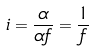<formula> <loc_0><loc_0><loc_500><loc_500>i = \frac { \alpha } { \alpha f } = \frac { 1 } { f }</formula> 